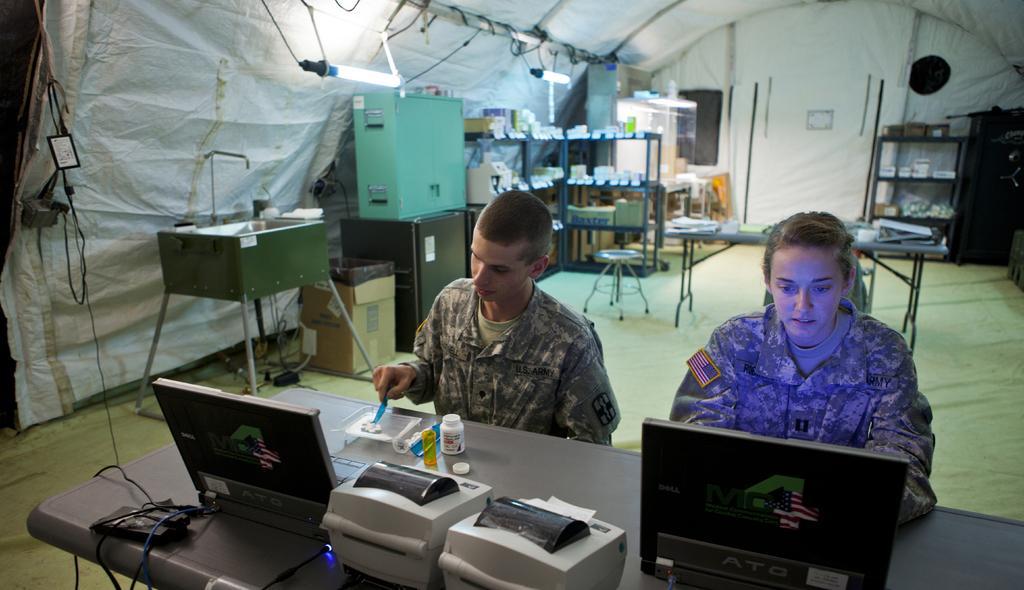Can you describe this image briefly? There is a woman sitting and operating a laptop in front of her which is placed on the table and there are few other objects beside it and there is another person sitting beside her and there are few other objects in the background. 